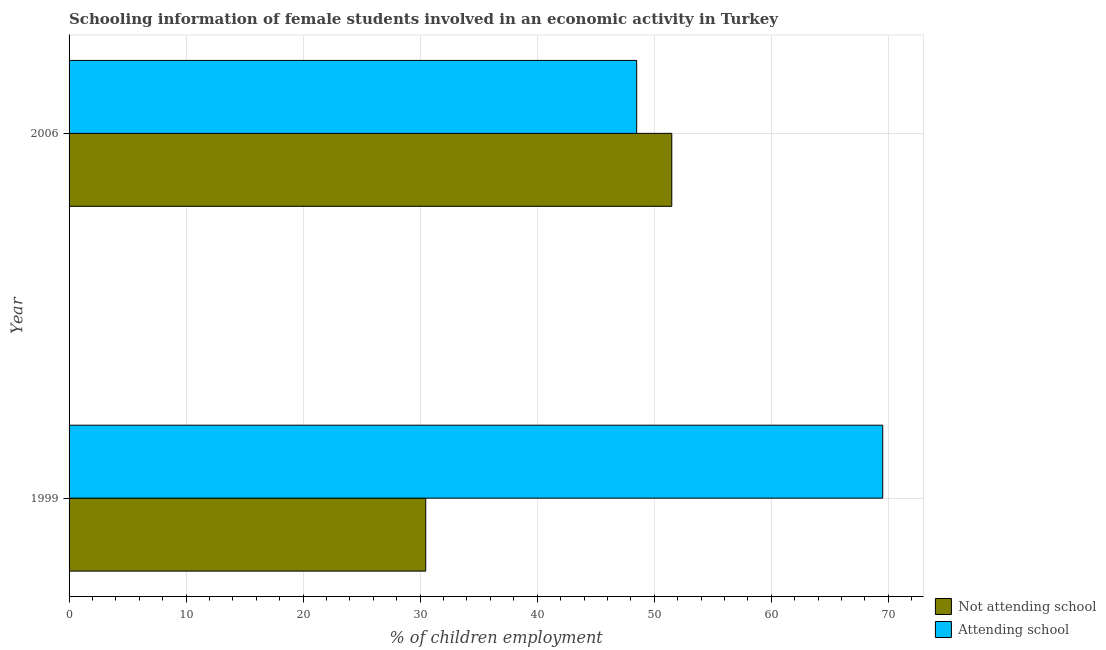Are the number of bars on each tick of the Y-axis equal?
Provide a short and direct response. Yes. How many bars are there on the 2nd tick from the top?
Give a very brief answer. 2. What is the label of the 1st group of bars from the top?
Provide a succinct answer. 2006. In how many cases, is the number of bars for a given year not equal to the number of legend labels?
Your answer should be very brief. 0. What is the percentage of employed females who are not attending school in 1999?
Give a very brief answer. 30.48. Across all years, what is the maximum percentage of employed females who are not attending school?
Make the answer very short. 51.5. Across all years, what is the minimum percentage of employed females who are attending school?
Offer a terse response. 48.5. In which year was the percentage of employed females who are attending school maximum?
Provide a short and direct response. 1999. In which year was the percentage of employed females who are attending school minimum?
Offer a very short reply. 2006. What is the total percentage of employed females who are not attending school in the graph?
Provide a succinct answer. 81.98. What is the difference between the percentage of employed females who are attending school in 1999 and that in 2006?
Your answer should be compact. 21.02. What is the difference between the percentage of employed females who are not attending school in 2006 and the percentage of employed females who are attending school in 1999?
Offer a very short reply. -18.02. What is the average percentage of employed females who are not attending school per year?
Offer a very short reply. 40.99. In the year 2006, what is the difference between the percentage of employed females who are attending school and percentage of employed females who are not attending school?
Give a very brief answer. -3. What is the ratio of the percentage of employed females who are not attending school in 1999 to that in 2006?
Give a very brief answer. 0.59. What does the 1st bar from the top in 2006 represents?
Give a very brief answer. Attending school. What does the 1st bar from the bottom in 2006 represents?
Make the answer very short. Not attending school. How many years are there in the graph?
Provide a succinct answer. 2. What is the difference between two consecutive major ticks on the X-axis?
Make the answer very short. 10. Are the values on the major ticks of X-axis written in scientific E-notation?
Ensure brevity in your answer.  No. Does the graph contain any zero values?
Your answer should be very brief. No. Does the graph contain grids?
Provide a short and direct response. Yes. What is the title of the graph?
Keep it short and to the point. Schooling information of female students involved in an economic activity in Turkey. Does "GDP per capita" appear as one of the legend labels in the graph?
Offer a terse response. No. What is the label or title of the X-axis?
Offer a terse response. % of children employment. What is the label or title of the Y-axis?
Your answer should be very brief. Year. What is the % of children employment of Not attending school in 1999?
Your answer should be compact. 30.48. What is the % of children employment in Attending school in 1999?
Offer a terse response. 69.52. What is the % of children employment of Not attending school in 2006?
Provide a succinct answer. 51.5. What is the % of children employment in Attending school in 2006?
Provide a succinct answer. 48.5. Across all years, what is the maximum % of children employment in Not attending school?
Your answer should be compact. 51.5. Across all years, what is the maximum % of children employment in Attending school?
Your response must be concise. 69.52. Across all years, what is the minimum % of children employment in Not attending school?
Keep it short and to the point. 30.48. Across all years, what is the minimum % of children employment of Attending school?
Ensure brevity in your answer.  48.5. What is the total % of children employment in Not attending school in the graph?
Keep it short and to the point. 81.98. What is the total % of children employment of Attending school in the graph?
Make the answer very short. 118.02. What is the difference between the % of children employment in Not attending school in 1999 and that in 2006?
Ensure brevity in your answer.  -21.02. What is the difference between the % of children employment of Attending school in 1999 and that in 2006?
Provide a short and direct response. 21.02. What is the difference between the % of children employment of Not attending school in 1999 and the % of children employment of Attending school in 2006?
Offer a very short reply. -18.02. What is the average % of children employment of Not attending school per year?
Your answer should be very brief. 40.99. What is the average % of children employment of Attending school per year?
Your response must be concise. 59.01. In the year 1999, what is the difference between the % of children employment in Not attending school and % of children employment in Attending school?
Your answer should be compact. -39.05. What is the ratio of the % of children employment of Not attending school in 1999 to that in 2006?
Offer a very short reply. 0.59. What is the ratio of the % of children employment of Attending school in 1999 to that in 2006?
Your answer should be compact. 1.43. What is the difference between the highest and the second highest % of children employment in Not attending school?
Your response must be concise. 21.02. What is the difference between the highest and the second highest % of children employment in Attending school?
Provide a short and direct response. 21.02. What is the difference between the highest and the lowest % of children employment of Not attending school?
Offer a terse response. 21.02. What is the difference between the highest and the lowest % of children employment of Attending school?
Make the answer very short. 21.02. 